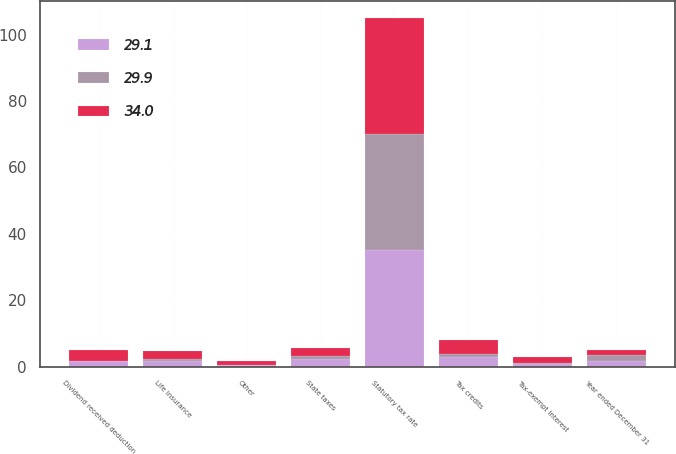Convert chart. <chart><loc_0><loc_0><loc_500><loc_500><stacked_bar_chart><ecel><fcel>Year ended December 31<fcel>Statutory tax rate<fcel>State taxes<fcel>Tax-exempt interest<fcel>Life insurance<fcel>Dividend received deduction<fcel>Tax credits<fcel>Other<nl><fcel>34<fcel>1.7<fcel>35<fcel>2.4<fcel>1.7<fcel>2.3<fcel>3.1<fcel>4.2<fcel>1.1<nl><fcel>29.1<fcel>1.7<fcel>35<fcel>2.3<fcel>0.8<fcel>1.7<fcel>1.6<fcel>2.9<fcel>0.4<nl><fcel>29.9<fcel>1.7<fcel>35<fcel>0.8<fcel>0.3<fcel>0.6<fcel>0.2<fcel>0.9<fcel>0.2<nl></chart> 